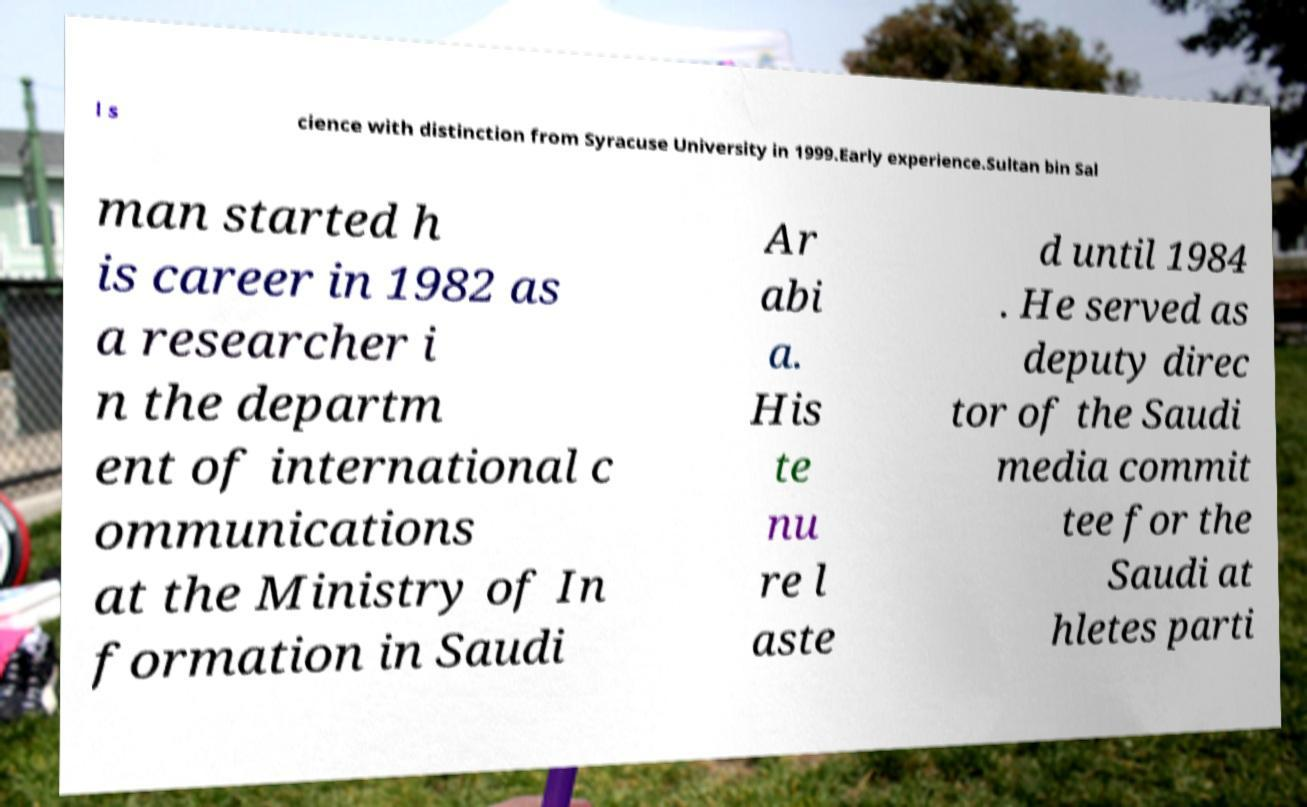Could you assist in decoding the text presented in this image and type it out clearly? l s cience with distinction from Syracuse University in 1999.Early experience.Sultan bin Sal man started h is career in 1982 as a researcher i n the departm ent of international c ommunications at the Ministry of In formation in Saudi Ar abi a. His te nu re l aste d until 1984 . He served as deputy direc tor of the Saudi media commit tee for the Saudi at hletes parti 